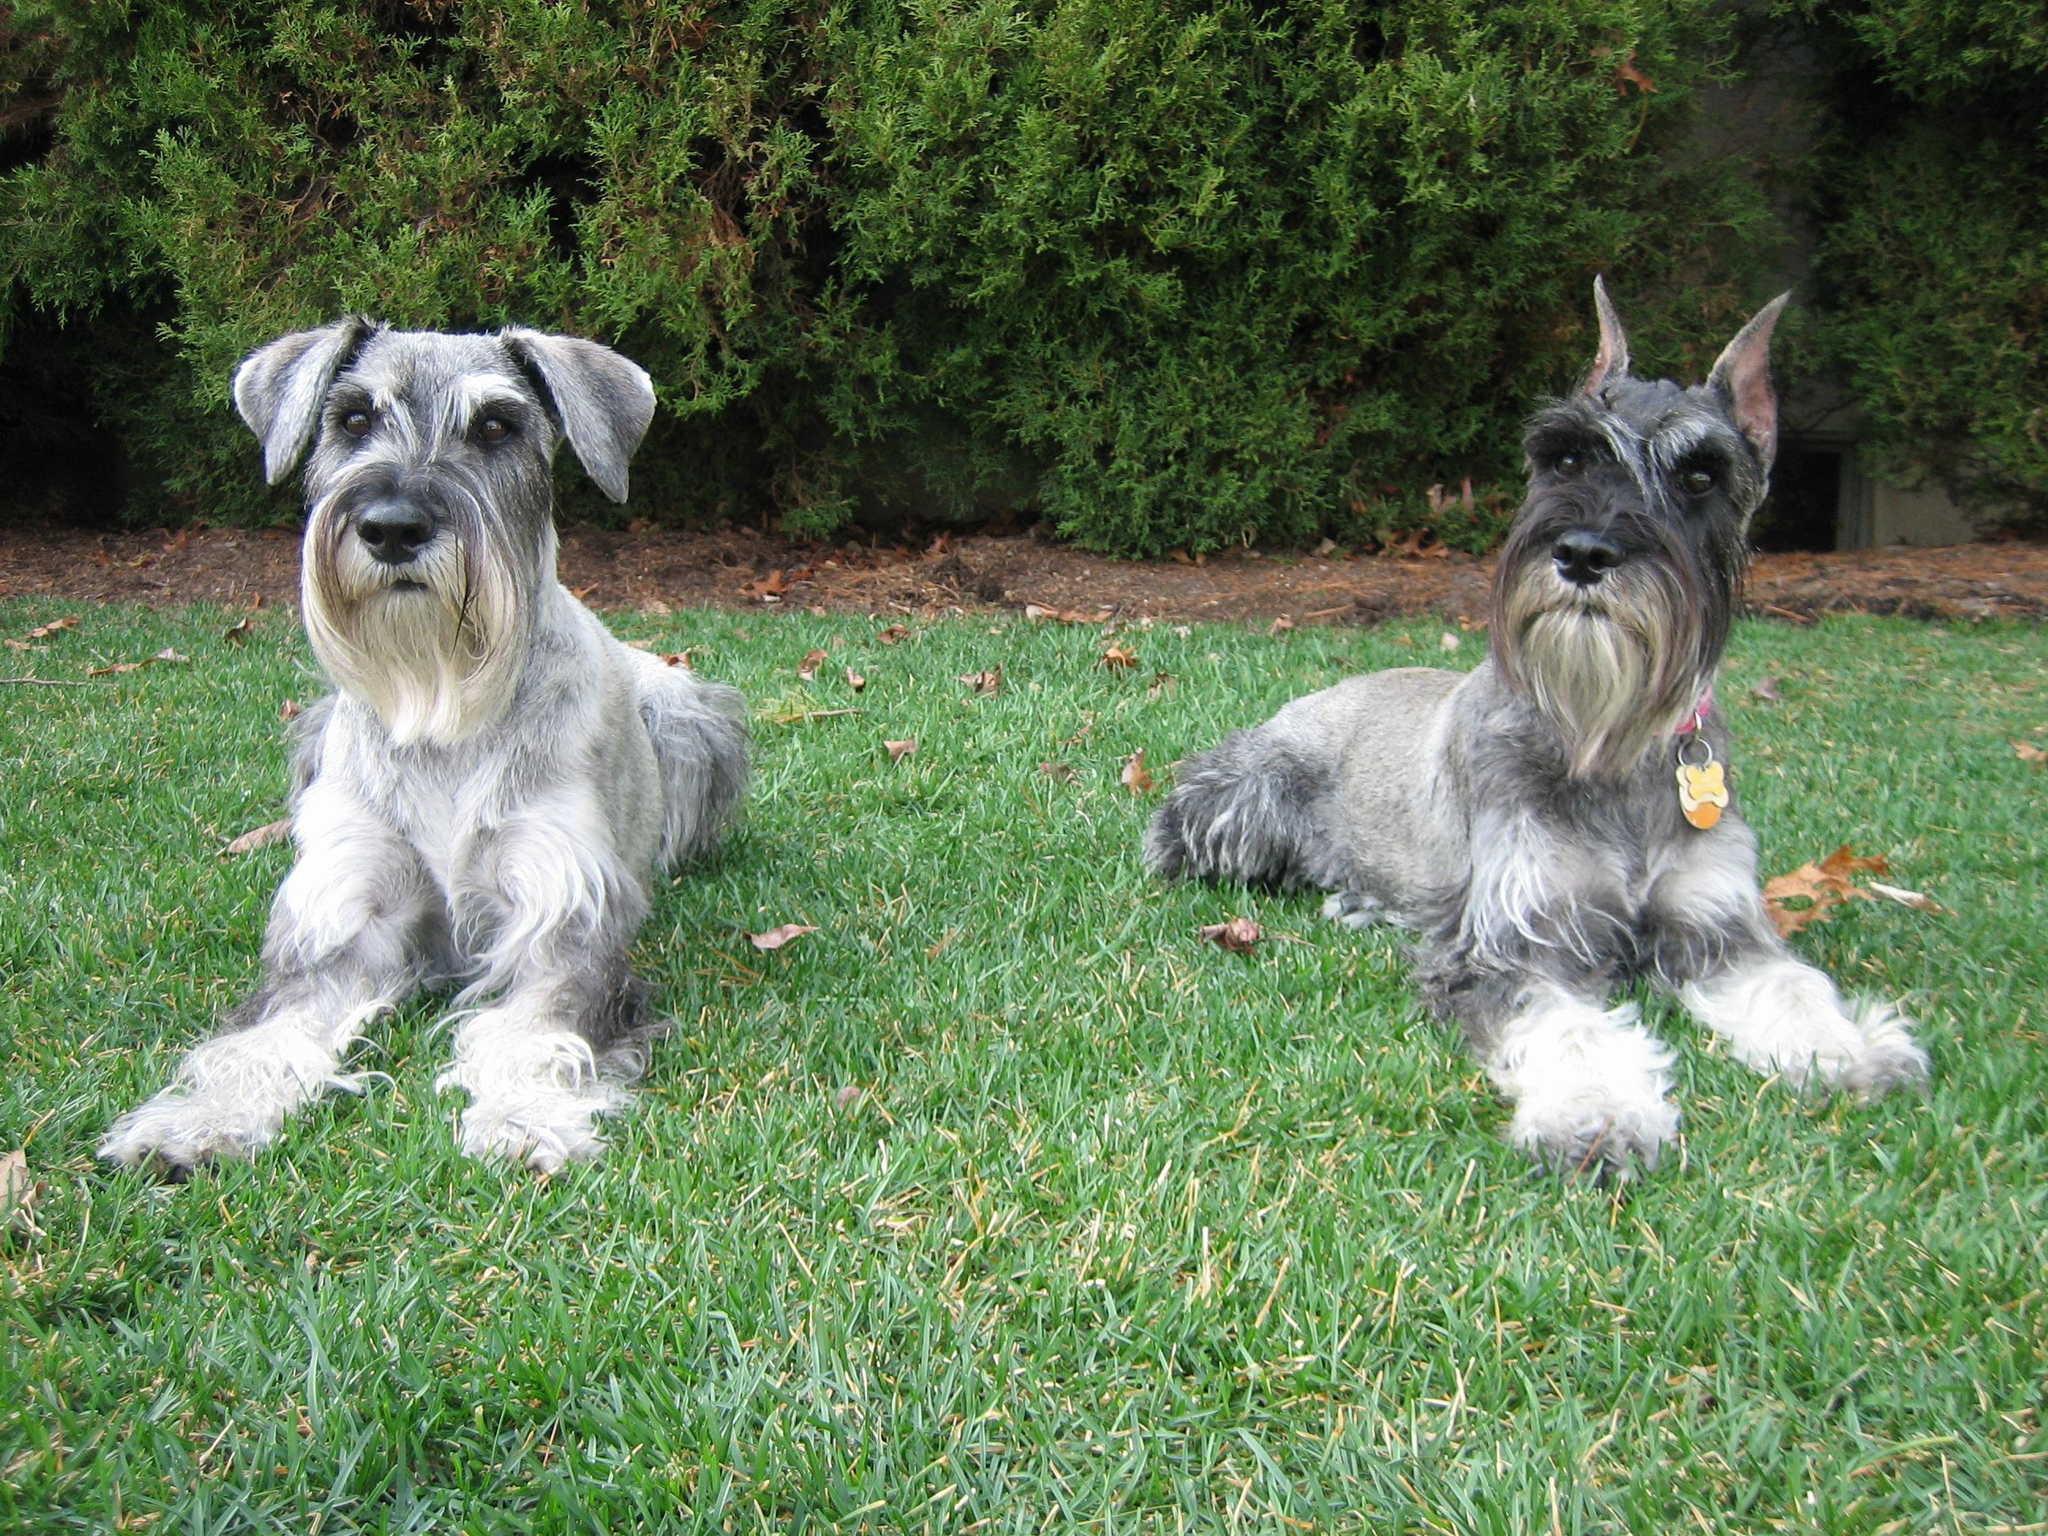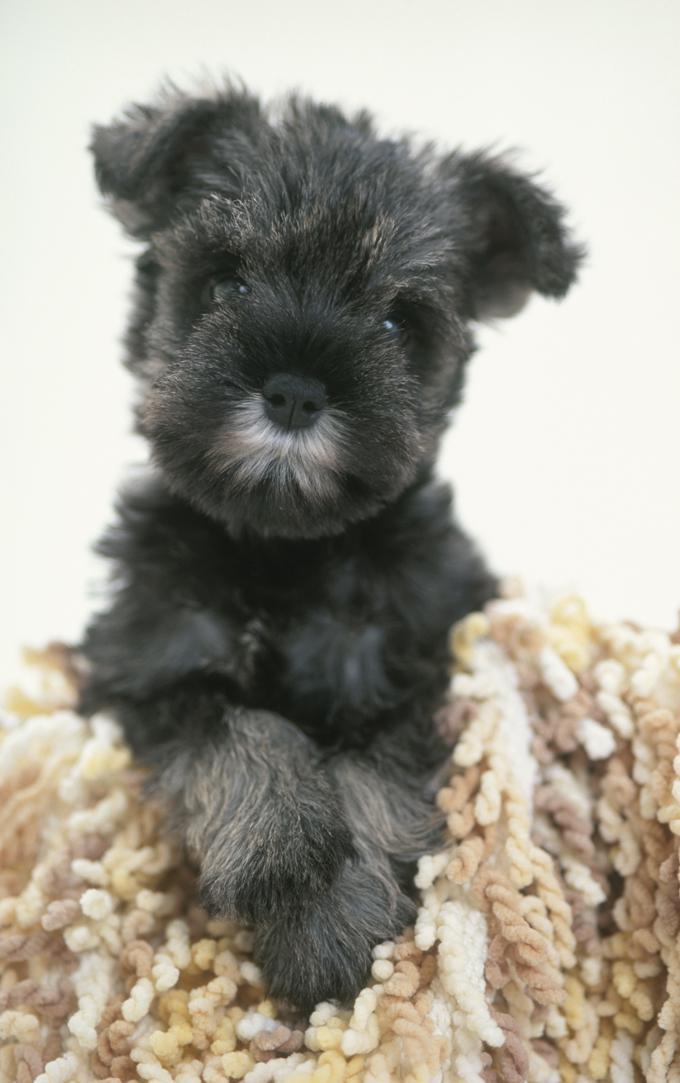The first image is the image on the left, the second image is the image on the right. Considering the images on both sides, is "One image shows two schnauzers on the grass." valid? Answer yes or no. Yes. The first image is the image on the left, the second image is the image on the right. Given the left and right images, does the statement "One dog has pointy ears and two dogs have ears turned down." hold true? Answer yes or no. Yes. 